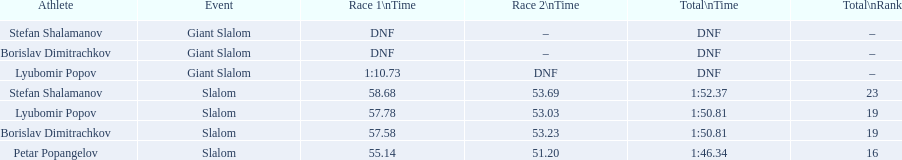Which events did lyubomir popov compete in? Lyubomir Popov, Lyubomir Popov. From those, which involved giant slalom races? Giant Slalom. What was his performance time in the opening race? 1:10.73. 